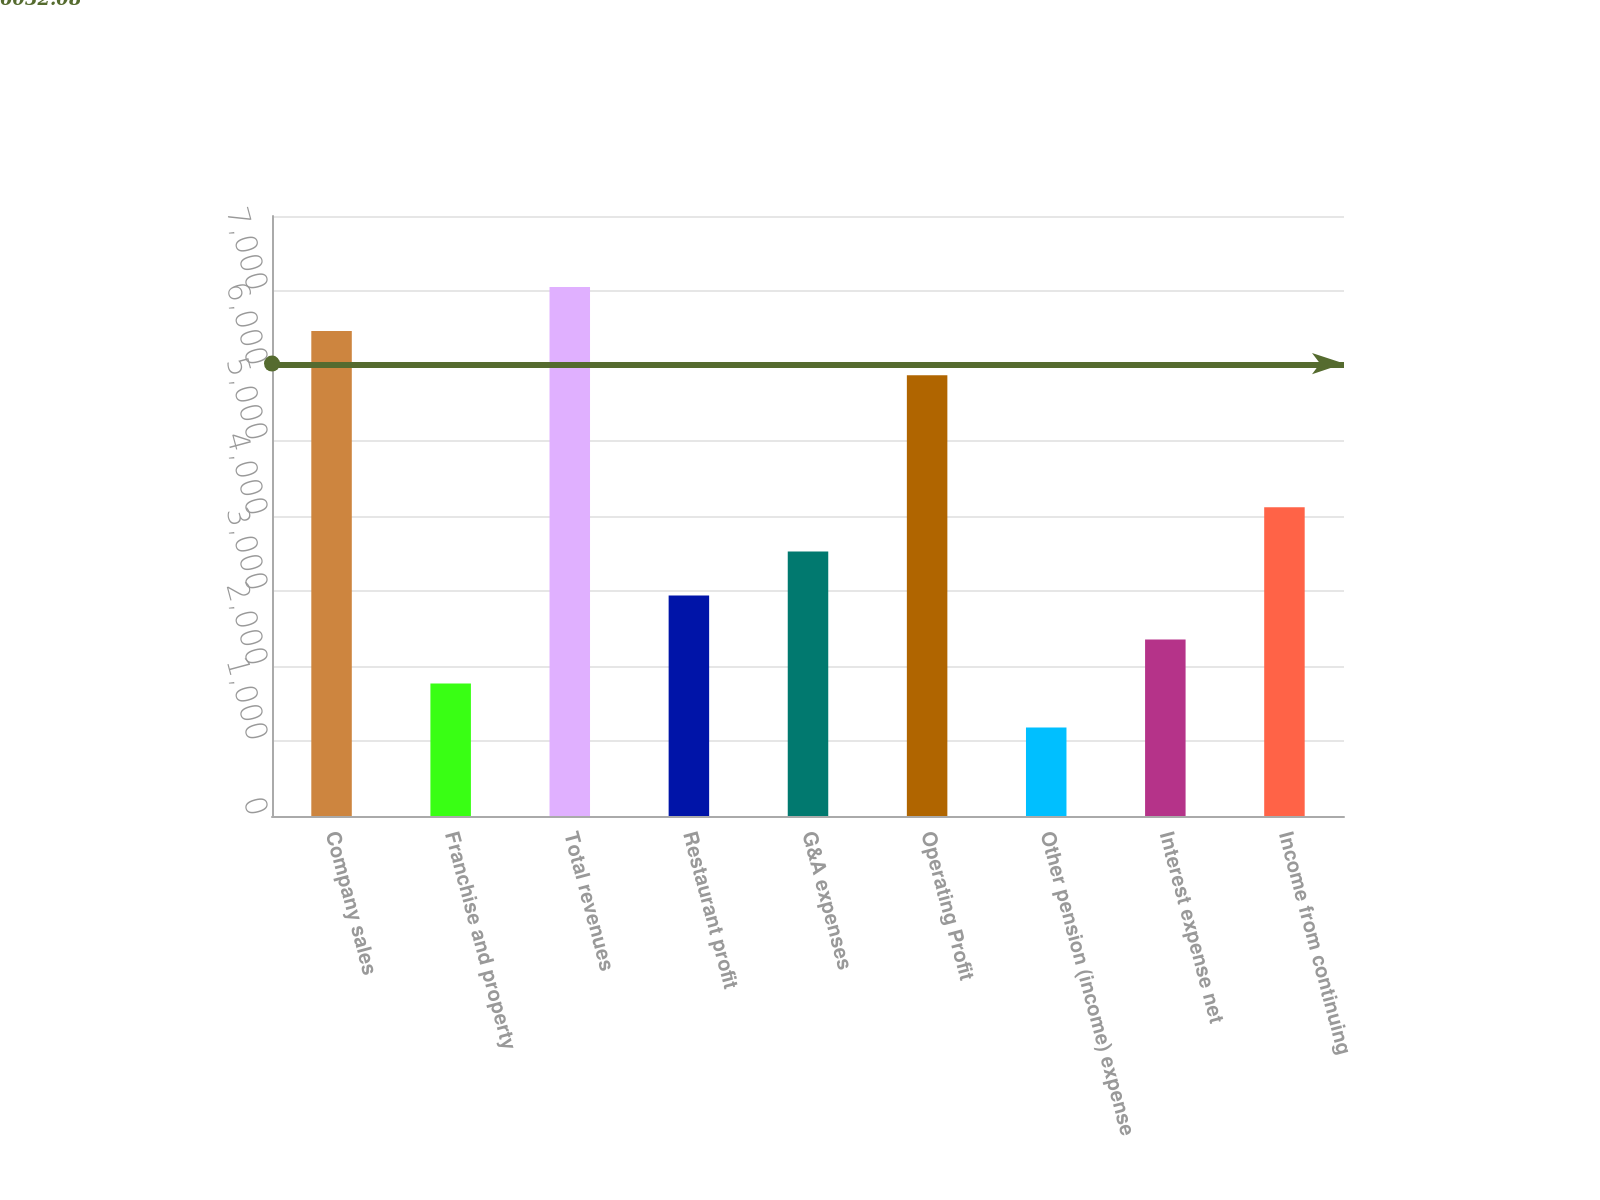<chart> <loc_0><loc_0><loc_500><loc_500><bar_chart><fcel>Company sales<fcel>Franchise and property<fcel>Total revenues<fcel>Restaurant profit<fcel>G&A expenses<fcel>Operating Profit<fcel>Other pension (income) expense<fcel>Interest expense net<fcel>Income from continuing<nl><fcel>6465.39<fcel>1766.03<fcel>7052.81<fcel>2940.87<fcel>3528.29<fcel>5877.97<fcel>1178.61<fcel>2353.45<fcel>4115.71<nl></chart> 